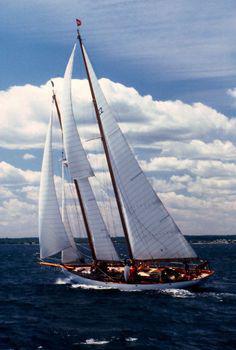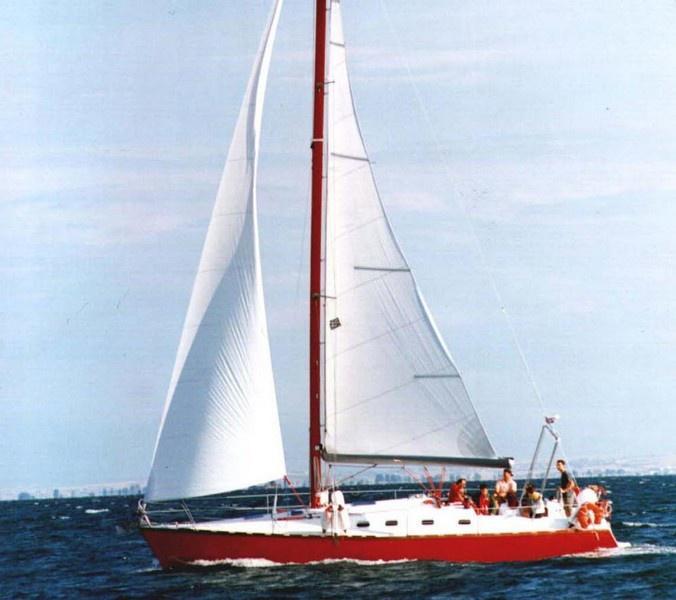The first image is the image on the left, the second image is the image on the right. For the images displayed, is the sentence "One of the boats only has two sails [unfurled]." factually correct? Answer yes or no. Yes. The first image is the image on the left, the second image is the image on the right. For the images shown, is this caption "The sail boat in the right image has three sails engaged." true? Answer yes or no. No. 